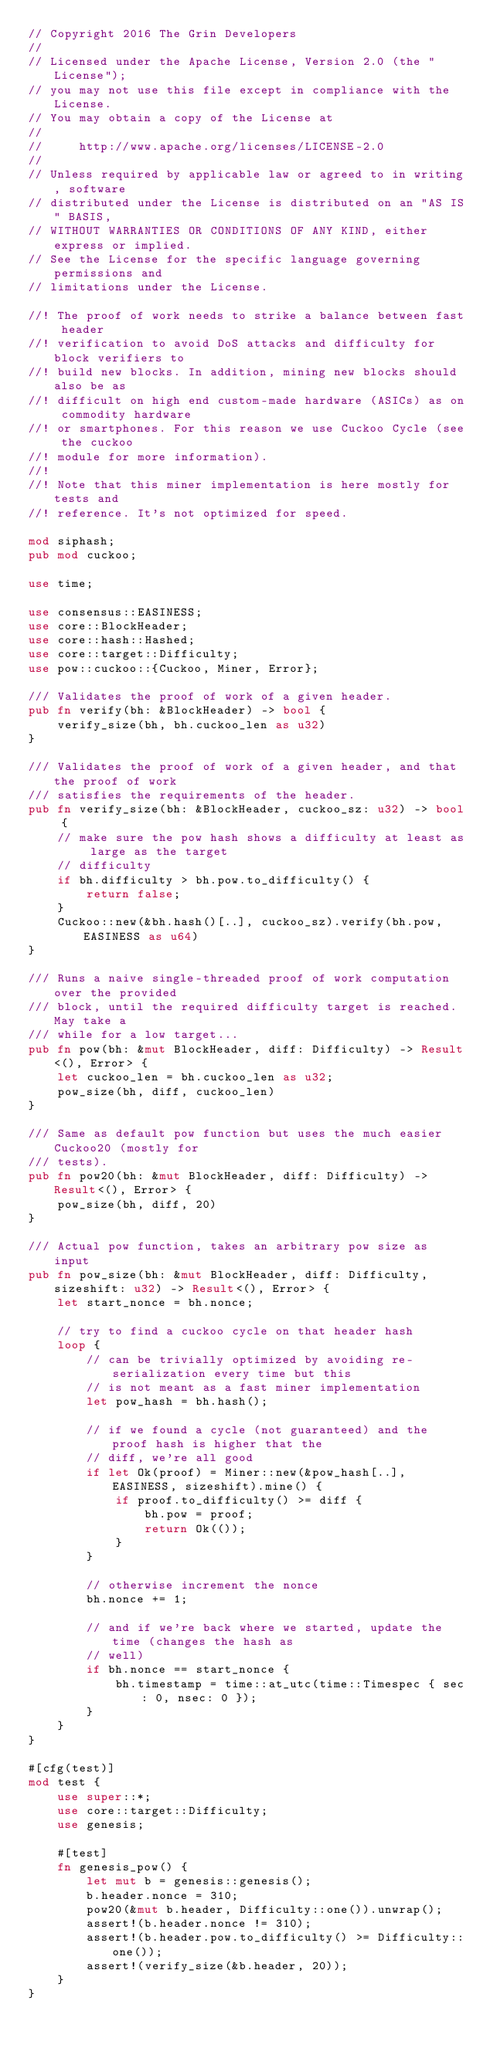<code> <loc_0><loc_0><loc_500><loc_500><_Rust_>// Copyright 2016 The Grin Developers
//
// Licensed under the Apache License, Version 2.0 (the "License");
// you may not use this file except in compliance with the License.
// You may obtain a copy of the License at
//
//     http://www.apache.org/licenses/LICENSE-2.0
//
// Unless required by applicable law or agreed to in writing, software
// distributed under the License is distributed on an "AS IS" BASIS,
// WITHOUT WARRANTIES OR CONDITIONS OF ANY KIND, either express or implied.
// See the License for the specific language governing permissions and
// limitations under the License.

//! The proof of work needs to strike a balance between fast header
//! verification to avoid DoS attacks and difficulty for block verifiers to
//! build new blocks. In addition, mining new blocks should also be as
//! difficult on high end custom-made hardware (ASICs) as on commodity hardware
//! or smartphones. For this reason we use Cuckoo Cycle (see the cuckoo
//! module for more information).
//!
//! Note that this miner implementation is here mostly for tests and
//! reference. It's not optimized for speed.

mod siphash;
pub mod cuckoo;

use time;

use consensus::EASINESS;
use core::BlockHeader;
use core::hash::Hashed;
use core::target::Difficulty;
use pow::cuckoo::{Cuckoo, Miner, Error};

/// Validates the proof of work of a given header.
pub fn verify(bh: &BlockHeader) -> bool {
	verify_size(bh, bh.cuckoo_len as u32)
}

/// Validates the proof of work of a given header, and that the proof of work
/// satisfies the requirements of the header.
pub fn verify_size(bh: &BlockHeader, cuckoo_sz: u32) -> bool {
	// make sure the pow hash shows a difficulty at least as large as the target
	// difficulty
	if bh.difficulty > bh.pow.to_difficulty() {
		return false;
	}
	Cuckoo::new(&bh.hash()[..], cuckoo_sz).verify(bh.pow, EASINESS as u64)
}

/// Runs a naive single-threaded proof of work computation over the provided
/// block, until the required difficulty target is reached. May take a
/// while for a low target...
pub fn pow(bh: &mut BlockHeader, diff: Difficulty) -> Result<(), Error> {
	let cuckoo_len = bh.cuckoo_len as u32;
	pow_size(bh, diff, cuckoo_len)
}

/// Same as default pow function but uses the much easier Cuckoo20 (mostly for
/// tests).
pub fn pow20(bh: &mut BlockHeader, diff: Difficulty) -> Result<(), Error> {
	pow_size(bh, diff, 20)
}

/// Actual pow function, takes an arbitrary pow size as input
pub fn pow_size(bh: &mut BlockHeader, diff: Difficulty, sizeshift: u32) -> Result<(), Error> {
	let start_nonce = bh.nonce;

	// try to find a cuckoo cycle on that header hash
	loop {
		// can be trivially optimized by avoiding re-serialization every time but this
		// is not meant as a fast miner implementation
		let pow_hash = bh.hash();

		// if we found a cycle (not guaranteed) and the proof hash is higher that the
		// diff, we're all good
		if let Ok(proof) = Miner::new(&pow_hash[..], EASINESS, sizeshift).mine() {
			if proof.to_difficulty() >= diff {
				bh.pow = proof;
				return Ok(());
			}
		}

		// otherwise increment the nonce
		bh.nonce += 1;

		// and if we're back where we started, update the time (changes the hash as
		// well)
		if bh.nonce == start_nonce {
			bh.timestamp = time::at_utc(time::Timespec { sec: 0, nsec: 0 });
		}
	}
}

#[cfg(test)]
mod test {
	use super::*;
	use core::target::Difficulty;
	use genesis;

	#[test]
	fn genesis_pow() {
		let mut b = genesis::genesis();
		b.header.nonce = 310;
		pow20(&mut b.header, Difficulty::one()).unwrap();
		assert!(b.header.nonce != 310);
		assert!(b.header.pow.to_difficulty() >= Difficulty::one());
		assert!(verify_size(&b.header, 20));
	}
}
</code> 